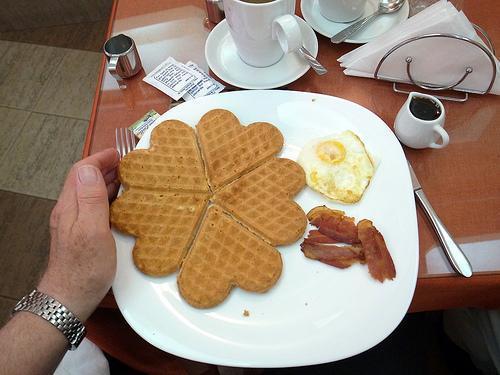How many eggs are there?
Give a very brief answer. 1. How many hearts are shown?
Give a very brief answer. 5. 